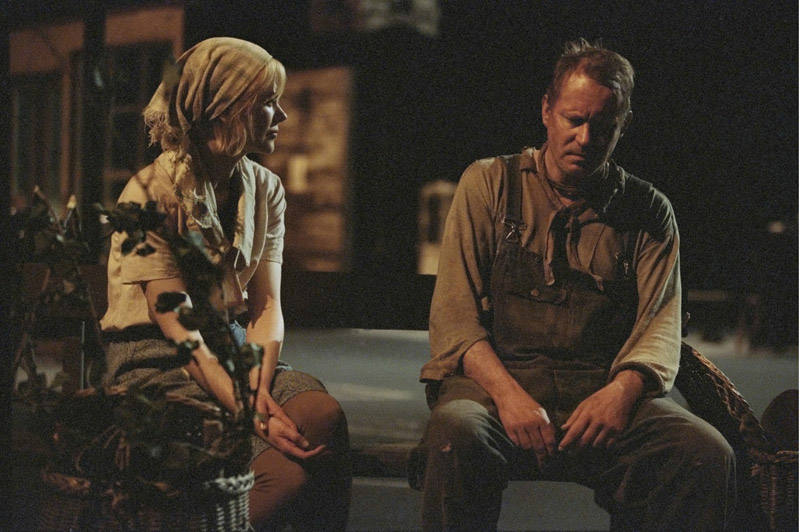What emotions do you think the individuals in this image are experiencing? The man appears to be engulfed in deep contemplation or sadness. His slouched posture and distant stare suggest he is overwhelmed by burdens unknown to us. The young woman’s expression and posture, leaning slightly towards him, indicate concern and empathy. She might be trying to offer support, sharing in the man's silent grief or worry. What might be the relationship between these two people? Based on their body language, the young woman and the older man could have a close relationship, perhaps a familial one. The interaction hints at a father-daughter dynamic, where the daughter is providing support to her father during a difficult moment. However, it could also be an interaction between two close friends or partners sharing a quiet but significant moment of understanding. 